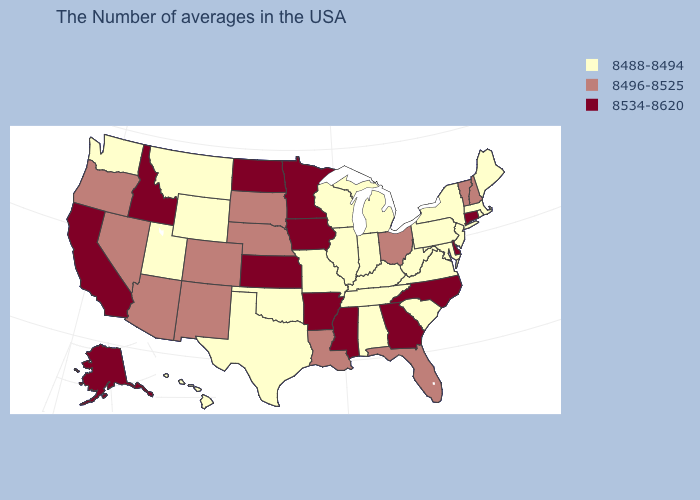What is the highest value in states that border Virginia?
Answer briefly. 8534-8620. Which states have the lowest value in the USA?
Concise answer only. Maine, Massachusetts, Rhode Island, New York, New Jersey, Maryland, Pennsylvania, Virginia, South Carolina, West Virginia, Michigan, Kentucky, Indiana, Alabama, Tennessee, Wisconsin, Illinois, Missouri, Oklahoma, Texas, Wyoming, Utah, Montana, Washington, Hawaii. Which states have the lowest value in the USA?
Write a very short answer. Maine, Massachusetts, Rhode Island, New York, New Jersey, Maryland, Pennsylvania, Virginia, South Carolina, West Virginia, Michigan, Kentucky, Indiana, Alabama, Tennessee, Wisconsin, Illinois, Missouri, Oklahoma, Texas, Wyoming, Utah, Montana, Washington, Hawaii. What is the lowest value in the USA?
Concise answer only. 8488-8494. Among the states that border Connecticut , which have the lowest value?
Write a very short answer. Massachusetts, Rhode Island, New York. What is the value of Mississippi?
Answer briefly. 8534-8620. Name the states that have a value in the range 8488-8494?
Give a very brief answer. Maine, Massachusetts, Rhode Island, New York, New Jersey, Maryland, Pennsylvania, Virginia, South Carolina, West Virginia, Michigan, Kentucky, Indiana, Alabama, Tennessee, Wisconsin, Illinois, Missouri, Oklahoma, Texas, Wyoming, Utah, Montana, Washington, Hawaii. What is the value of Maryland?
Be succinct. 8488-8494. What is the value of North Carolina?
Be succinct. 8534-8620. How many symbols are there in the legend?
Be succinct. 3. What is the value of Tennessee?
Concise answer only. 8488-8494. Among the states that border New Hampshire , does Vermont have the lowest value?
Be succinct. No. Does Arizona have a higher value than Georgia?
Answer briefly. No. What is the lowest value in the USA?
Keep it brief. 8488-8494. 